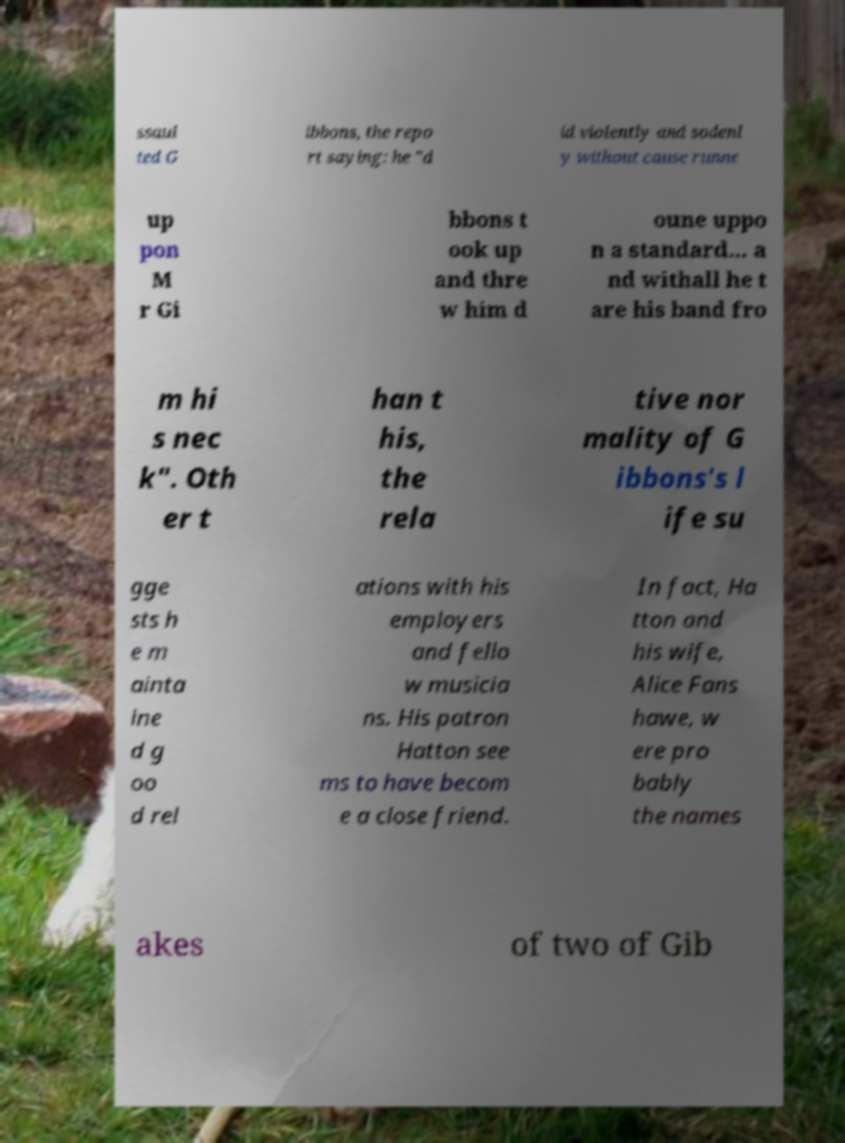Can you read and provide the text displayed in the image?This photo seems to have some interesting text. Can you extract and type it out for me? ssaul ted G ibbons, the repo rt saying: he "d id violently and sodenl y without cause runne up pon M r Gi bbons t ook up and thre w him d oune uppo n a standard... a nd withall he t are his band fro m hi s nec k". Oth er t han t his, the rela tive nor mality of G ibbons's l ife su gge sts h e m ainta ine d g oo d rel ations with his employers and fello w musicia ns. His patron Hatton see ms to have becom e a close friend. In fact, Ha tton and his wife, Alice Fans hawe, w ere pro bably the names akes of two of Gib 